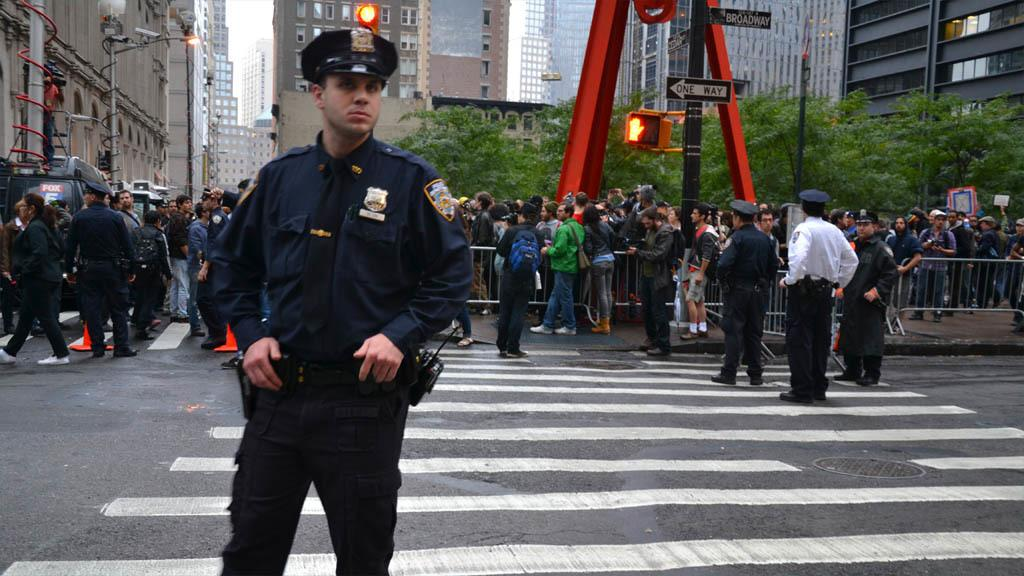What is the main subject of the image? There is a man standing in the middle of the image. What is the man doing in the image? The man is watching something. Are there any other people in the image? Yes, there are people standing behind the man. What are the people behind the man doing? The people are also watching something. What can be seen in the background of the image? There is fencing, poles, trees, sign boards, and buildings in the image. How many ants can be seen crawling on the man's chin in the image? There are no ants visible on the man's chin in the image. Is there a jail present in the image? There is no jail depicted in the image. 